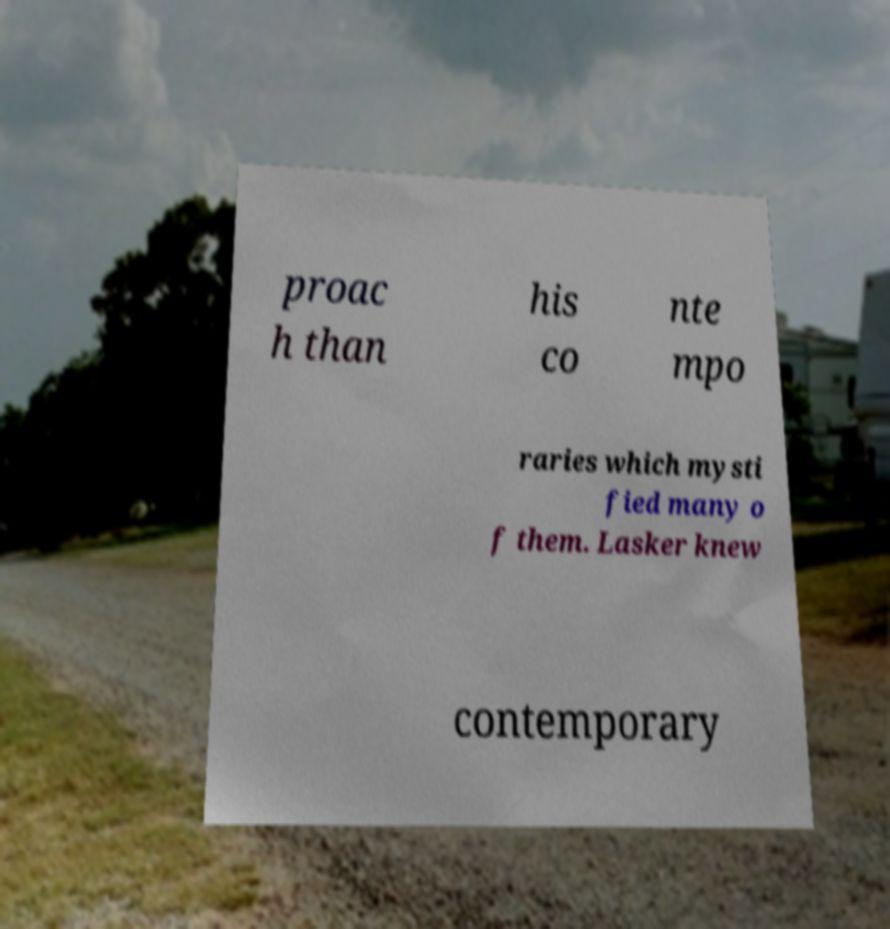Could you assist in decoding the text presented in this image and type it out clearly? proac h than his co nte mpo raries which mysti fied many o f them. Lasker knew contemporary 